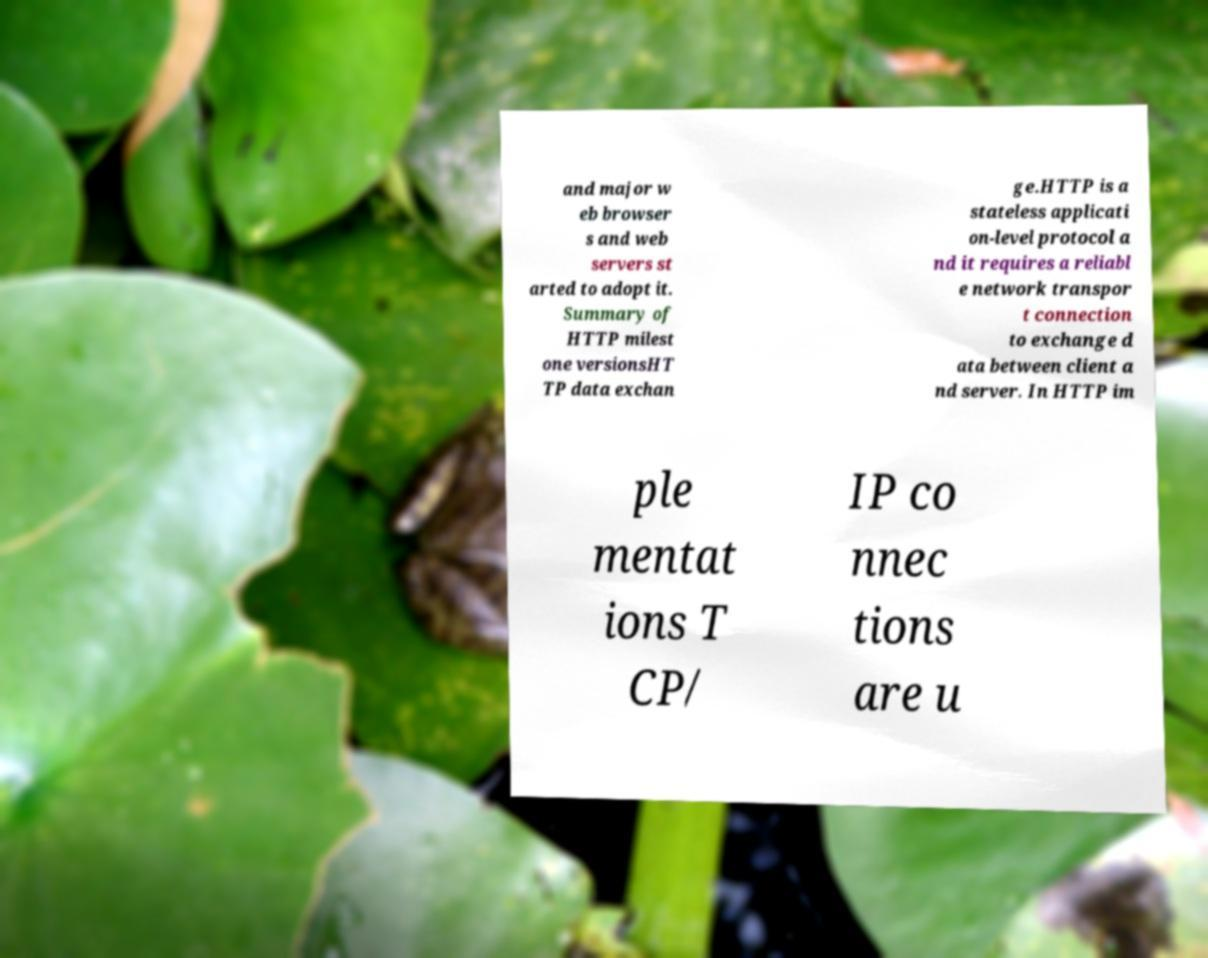Could you assist in decoding the text presented in this image and type it out clearly? and major w eb browser s and web servers st arted to adopt it. Summary of HTTP milest one versionsHT TP data exchan ge.HTTP is a stateless applicati on-level protocol a nd it requires a reliabl e network transpor t connection to exchange d ata between client a nd server. In HTTP im ple mentat ions T CP/ IP co nnec tions are u 